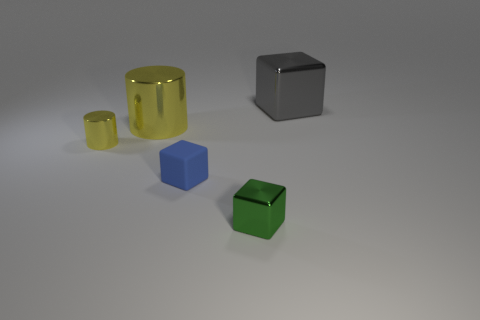There is a small shiny thing that is the same color as the big cylinder; what is its shape?
Give a very brief answer. Cylinder. There is a cube that is both behind the green thing and to the left of the big cube; what color is it?
Your answer should be very brief. Blue. There is a cylinder behind the small shiny thing that is on the left side of the large metal object that is in front of the big gray shiny object; what is it made of?
Offer a terse response. Metal. What is the small blue thing made of?
Your answer should be very brief. Rubber. What is the size of the gray shiny thing that is the same shape as the small matte object?
Make the answer very short. Large. Is the big shiny block the same color as the small rubber cube?
Provide a short and direct response. No. How many other things are there of the same material as the green cube?
Your response must be concise. 3. Are there the same number of blue blocks left of the small blue thing and large red rubber blocks?
Your answer should be compact. Yes. There is a object that is in front of the rubber object; is its size the same as the large gray metal thing?
Keep it short and to the point. No. There is a tiny green object; how many small matte objects are to the right of it?
Keep it short and to the point. 0. 